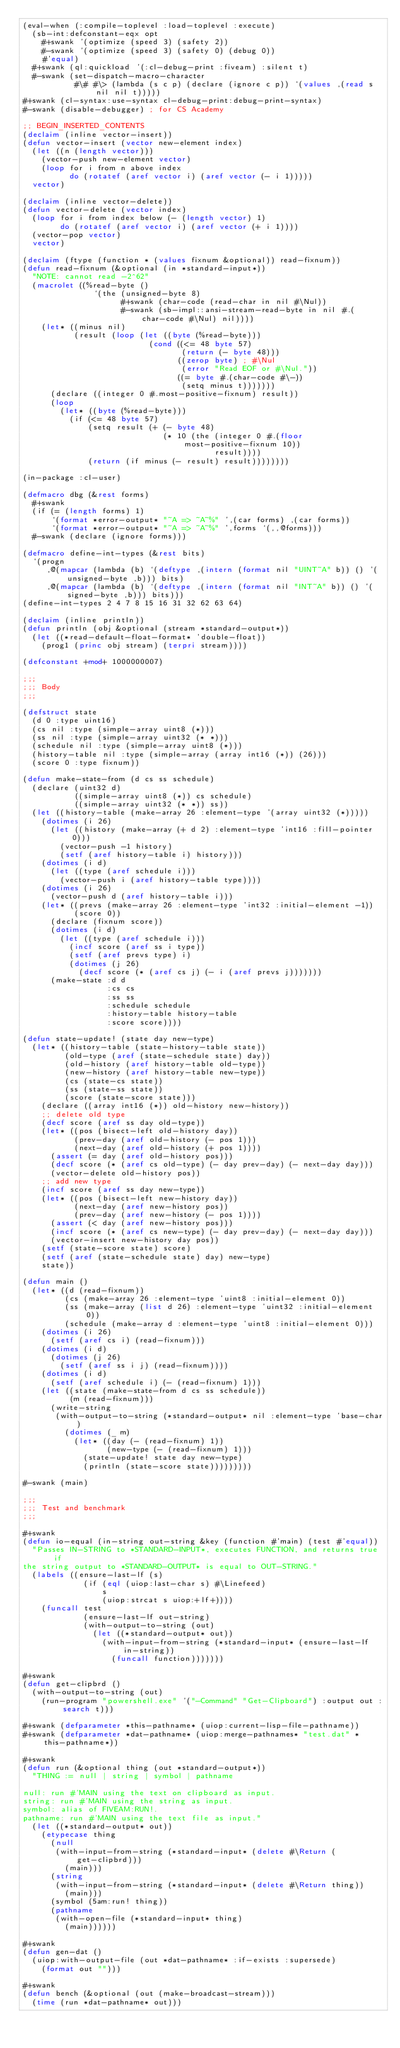<code> <loc_0><loc_0><loc_500><loc_500><_Lisp_>(eval-when (:compile-toplevel :load-toplevel :execute)
  (sb-int:defconstant-eqx opt
    #+swank '(optimize (speed 3) (safety 2))
    #-swank '(optimize (speed 3) (safety 0) (debug 0))
    #'equal)
  #+swank (ql:quickload '(:cl-debug-print :fiveam) :silent t)
  #-swank (set-dispatch-macro-character
           #\# #\> (lambda (s c p) (declare (ignore c p)) `(values ,(read s nil nil t)))))
#+swank (cl-syntax:use-syntax cl-debug-print:debug-print-syntax)
#-swank (disable-debugger) ; for CS Academy

;; BEGIN_INSERTED_CONTENTS
(declaim (inline vector-insert))
(defun vector-insert (vector new-element index)
  (let ((n (length vector)))
    (vector-push new-element vector)
    (loop for i from n above index
          do (rotatef (aref vector i) (aref vector (- i 1)))))
  vector)

(declaim (inline vector-delete))
(defun vector-delete (vector index)
  (loop for i from index below (- (length vector) 1)
        do (rotatef (aref vector i) (aref vector (+ i 1))))
  (vector-pop vector)
  vector)

(declaim (ftype (function * (values fixnum &optional)) read-fixnum))
(defun read-fixnum (&optional (in *standard-input*))
  "NOTE: cannot read -2^62"
  (macrolet ((%read-byte ()
               `(the (unsigned-byte 8)
                     #+swank (char-code (read-char in nil #\Nul))
                     #-swank (sb-impl::ansi-stream-read-byte in nil #.(char-code #\Nul) nil))))
    (let* ((minus nil)
           (result (loop (let ((byte (%read-byte)))
                           (cond ((<= 48 byte 57)
                                  (return (- byte 48)))
                                 ((zerop byte) ; #\Nul
                                  (error "Read EOF or #\Nul."))
                                 ((= byte #.(char-code #\-))
                                  (setq minus t)))))))
      (declare ((integer 0 #.most-positive-fixnum) result))
      (loop
        (let* ((byte (%read-byte)))
          (if (<= 48 byte 57)
              (setq result (+ (- byte 48)
                              (* 10 (the (integer 0 #.(floor most-positive-fixnum 10))
                                         result))))
              (return (if minus (- result) result))))))))

(in-package :cl-user)

(defmacro dbg (&rest forms)
  #+swank
  (if (= (length forms) 1)
      `(format *error-output* "~A => ~A~%" ',(car forms) ,(car forms))
      `(format *error-output* "~A => ~A~%" ',forms `(,,@forms)))
  #-swank (declare (ignore forms)))

(defmacro define-int-types (&rest bits)
  `(progn
     ,@(mapcar (lambda (b) `(deftype ,(intern (format nil "UINT~A" b)) () '(unsigned-byte ,b))) bits)
     ,@(mapcar (lambda (b) `(deftype ,(intern (format nil "INT~A" b)) () '(signed-byte ,b))) bits)))
(define-int-types 2 4 7 8 15 16 31 32 62 63 64)

(declaim (inline println))
(defun println (obj &optional (stream *standard-output*))
  (let ((*read-default-float-format* 'double-float))
    (prog1 (princ obj stream) (terpri stream))))

(defconstant +mod+ 1000000007)

;;;
;;; Body
;;;

(defstruct state
  (d 0 :type uint16)
  (cs nil :type (simple-array uint8 (*)))
  (ss nil :type (simple-array uint32 (* *)))
  (schedule nil :type (simple-array uint8 (*)))
  (history-table nil :type (simple-array (array int16 (*)) (26)))
  (score 0 :type fixnum))

(defun make-state-from (d cs ss schedule)
  (declare (uint32 d)
           ((simple-array uint8 (*)) cs schedule)
           ((simple-array uint32 (* *)) ss))
  (let ((history-table (make-array 26 :element-type '(array uint32 (*)))))
    (dotimes (i 26)
      (let ((history (make-array (+ d 2) :element-type 'int16 :fill-pointer 0)))
        (vector-push -1 history)
        (setf (aref history-table i) history)))
    (dotimes (i d)
      (let ((type (aref schedule i)))
        (vector-push i (aref history-table type))))
    (dotimes (i 26)
      (vector-push d (aref history-table i)))
    (let* ((prevs (make-array 26 :element-type 'int32 :initial-element -1))
           (score 0))
      (declare (fixnum score))
      (dotimes (i d)
        (let ((type (aref schedule i)))
          (incf score (aref ss i type))
          (setf (aref prevs type) i)
          (dotimes (j 26)
            (decf score (* (aref cs j) (- i (aref prevs j)))))))
      (make-state :d d
                  :cs cs
                  :ss ss
                  :schedule schedule
                  :history-table history-table
                  :score score))))

(defun state-update! (state day new-type)
  (let* ((history-table (state-history-table state))
         (old-type (aref (state-schedule state) day))
         (old-history (aref history-table old-type))
         (new-history (aref history-table new-type))
         (cs (state-cs state))
         (ss (state-ss state))
         (score (state-score state)))
    (declare ((array int16 (*)) old-history new-history))
    ;; delete old type
    (decf score (aref ss day old-type))
    (let* ((pos (bisect-left old-history day))
           (prev-day (aref old-history (- pos 1)))
           (next-day (aref old-history (+ pos 1))))
      (assert (= day (aref old-history pos)))
      (decf score (* (aref cs old-type) (- day prev-day) (- next-day day)))
      (vector-delete old-history pos))
    ;; add new type 
    (incf score (aref ss day new-type))
    (let* ((pos (bisect-left new-history day))
           (next-day (aref new-history pos))
           (prev-day (aref new-history (- pos 1))))
      (assert (< day (aref new-history pos)))
      (incf score (* (aref cs new-type) (- day prev-day) (- next-day day)))
      (vector-insert new-history day pos))
    (setf (state-score state) score)
    (setf (aref (state-schedule state) day) new-type)
    state))

(defun main ()
  (let* ((d (read-fixnum))
         (cs (make-array 26 :element-type 'uint8 :initial-element 0))
         (ss (make-array (list d 26) :element-type 'uint32 :initial-element 0))
         (schedule (make-array d :element-type 'uint8 :initial-element 0)))
    (dotimes (i 26)
      (setf (aref cs i) (read-fixnum)))
    (dotimes (i d)
      (dotimes (j 26)
        (setf (aref ss i j) (read-fixnum))))
    (dotimes (i d)
      (setf (aref schedule i) (- (read-fixnum) 1)))
    (let ((state (make-state-from d cs ss schedule))
          (m (read-fixnum)))
      (write-string
       (with-output-to-string (*standard-output* nil :element-type 'base-char)
         (dotimes (_ m)
           (let* ((day (- (read-fixnum) 1))
                  (new-type (- (read-fixnum) 1)))
             (state-update! state day new-type)
             (println (state-score state)))))))))

#-swank (main)

;;;
;;; Test and benchmark
;;;

#+swank
(defun io-equal (in-string out-string &key (function #'main) (test #'equal))
  "Passes IN-STRING to *STANDARD-INPUT*, executes FUNCTION, and returns true if
the string output to *STANDARD-OUTPUT* is equal to OUT-STRING."
  (labels ((ensure-last-lf (s)
             (if (eql (uiop:last-char s) #\Linefeed)
                 s
                 (uiop:strcat s uiop:+lf+))))
    (funcall test
             (ensure-last-lf out-string)
             (with-output-to-string (out)
               (let ((*standard-output* out))
                 (with-input-from-string (*standard-input* (ensure-last-lf in-string))
                   (funcall function)))))))

#+swank
(defun get-clipbrd ()
  (with-output-to-string (out)
    (run-program "powershell.exe" '("-Command" "Get-Clipboard") :output out :search t)))

#+swank (defparameter *this-pathname* (uiop:current-lisp-file-pathname))
#+swank (defparameter *dat-pathname* (uiop:merge-pathnames* "test.dat" *this-pathname*))

#+swank
(defun run (&optional thing (out *standard-output*))
  "THING := null | string | symbol | pathname

null: run #'MAIN using the text on clipboard as input.
string: run #'MAIN using the string as input.
symbol: alias of FIVEAM:RUN!.
pathname: run #'MAIN using the text file as input."
  (let ((*standard-output* out))
    (etypecase thing
      (null
       (with-input-from-string (*standard-input* (delete #\Return (get-clipbrd)))
         (main)))
      (string
       (with-input-from-string (*standard-input* (delete #\Return thing))
         (main)))
      (symbol (5am:run! thing))
      (pathname
       (with-open-file (*standard-input* thing)
         (main))))))

#+swank
(defun gen-dat ()
  (uiop:with-output-file (out *dat-pathname* :if-exists :supersede)
    (format out "")))

#+swank
(defun bench (&optional (out (make-broadcast-stream)))
  (time (run *dat-pathname* out)))
</code> 